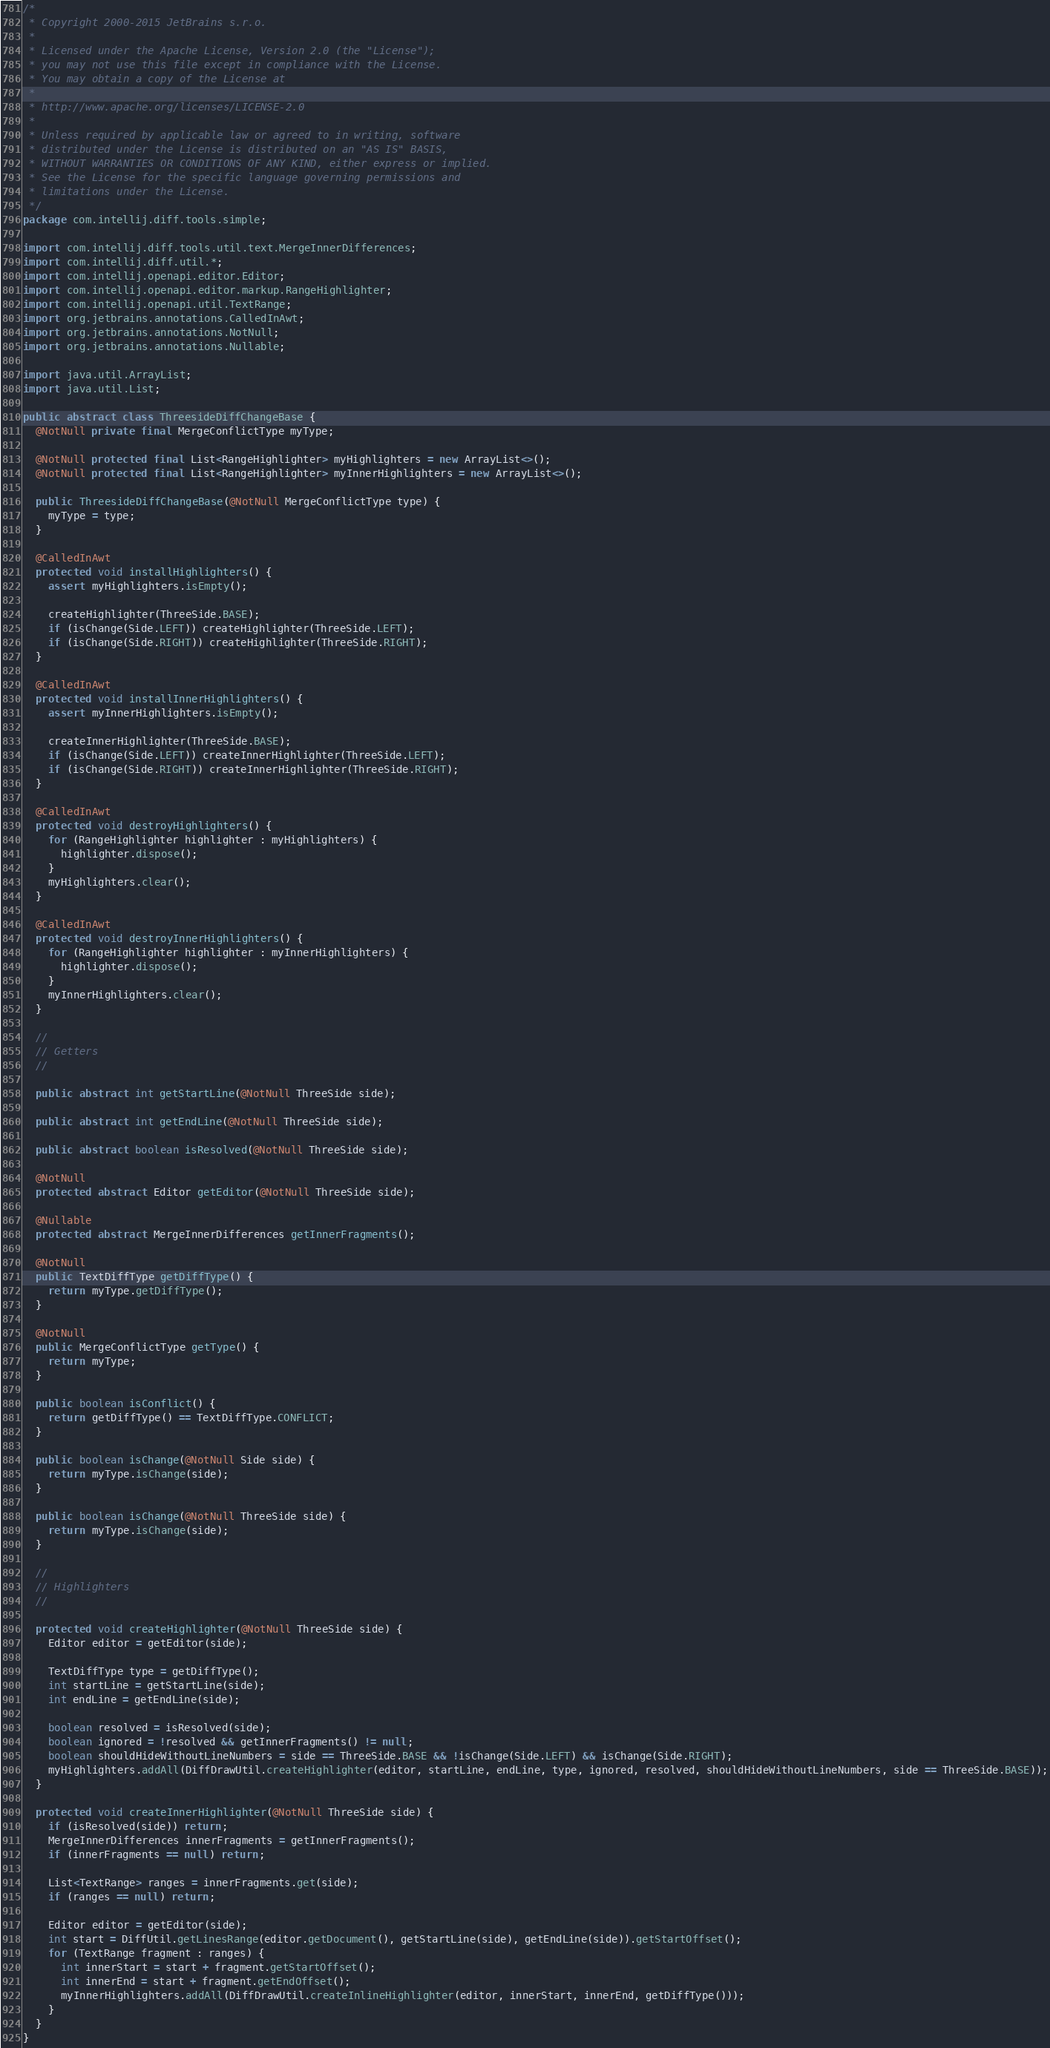<code> <loc_0><loc_0><loc_500><loc_500><_Java_>/*
 * Copyright 2000-2015 JetBrains s.r.o.
 *
 * Licensed under the Apache License, Version 2.0 (the "License");
 * you may not use this file except in compliance with the License.
 * You may obtain a copy of the License at
 *
 * http://www.apache.org/licenses/LICENSE-2.0
 *
 * Unless required by applicable law or agreed to in writing, software
 * distributed under the License is distributed on an "AS IS" BASIS,
 * WITHOUT WARRANTIES OR CONDITIONS OF ANY KIND, either express or implied.
 * See the License for the specific language governing permissions and
 * limitations under the License.
 */
package com.intellij.diff.tools.simple;

import com.intellij.diff.tools.util.text.MergeInnerDifferences;
import com.intellij.diff.util.*;
import com.intellij.openapi.editor.Editor;
import com.intellij.openapi.editor.markup.RangeHighlighter;
import com.intellij.openapi.util.TextRange;
import org.jetbrains.annotations.CalledInAwt;
import org.jetbrains.annotations.NotNull;
import org.jetbrains.annotations.Nullable;

import java.util.ArrayList;
import java.util.List;

public abstract class ThreesideDiffChangeBase {
  @NotNull private final MergeConflictType myType;

  @NotNull protected final List<RangeHighlighter> myHighlighters = new ArrayList<>();
  @NotNull protected final List<RangeHighlighter> myInnerHighlighters = new ArrayList<>();

  public ThreesideDiffChangeBase(@NotNull MergeConflictType type) {
    myType = type;
  }

  @CalledInAwt
  protected void installHighlighters() {
    assert myHighlighters.isEmpty();

    createHighlighter(ThreeSide.BASE);
    if (isChange(Side.LEFT)) createHighlighter(ThreeSide.LEFT);
    if (isChange(Side.RIGHT)) createHighlighter(ThreeSide.RIGHT);
  }

  @CalledInAwt
  protected void installInnerHighlighters() {
    assert myInnerHighlighters.isEmpty();

    createInnerHighlighter(ThreeSide.BASE);
    if (isChange(Side.LEFT)) createInnerHighlighter(ThreeSide.LEFT);
    if (isChange(Side.RIGHT)) createInnerHighlighter(ThreeSide.RIGHT);
  }

  @CalledInAwt
  protected void destroyHighlighters() {
    for (RangeHighlighter highlighter : myHighlighters) {
      highlighter.dispose();
    }
    myHighlighters.clear();
  }

  @CalledInAwt
  protected void destroyInnerHighlighters() {
    for (RangeHighlighter highlighter : myInnerHighlighters) {
      highlighter.dispose();
    }
    myInnerHighlighters.clear();
  }

  //
  // Getters
  //

  public abstract int getStartLine(@NotNull ThreeSide side);

  public abstract int getEndLine(@NotNull ThreeSide side);

  public abstract boolean isResolved(@NotNull ThreeSide side);

  @NotNull
  protected abstract Editor getEditor(@NotNull ThreeSide side);

  @Nullable
  protected abstract MergeInnerDifferences getInnerFragments();

  @NotNull
  public TextDiffType getDiffType() {
    return myType.getDiffType();
  }

  @NotNull
  public MergeConflictType getType() {
    return myType;
  }

  public boolean isConflict() {
    return getDiffType() == TextDiffType.CONFLICT;
  }

  public boolean isChange(@NotNull Side side) {
    return myType.isChange(side);
  }

  public boolean isChange(@NotNull ThreeSide side) {
    return myType.isChange(side);
  }

  //
  // Highlighters
  //

  protected void createHighlighter(@NotNull ThreeSide side) {
    Editor editor = getEditor(side);

    TextDiffType type = getDiffType();
    int startLine = getStartLine(side);
    int endLine = getEndLine(side);

    boolean resolved = isResolved(side);
    boolean ignored = !resolved && getInnerFragments() != null;
    boolean shouldHideWithoutLineNumbers = side == ThreeSide.BASE && !isChange(Side.LEFT) && isChange(Side.RIGHT);
    myHighlighters.addAll(DiffDrawUtil.createHighlighter(editor, startLine, endLine, type, ignored, resolved, shouldHideWithoutLineNumbers, side == ThreeSide.BASE));
  }

  protected void createInnerHighlighter(@NotNull ThreeSide side) {
    if (isResolved(side)) return;
    MergeInnerDifferences innerFragments = getInnerFragments();
    if (innerFragments == null) return;

    List<TextRange> ranges = innerFragments.get(side);
    if (ranges == null) return;

    Editor editor = getEditor(side);
    int start = DiffUtil.getLinesRange(editor.getDocument(), getStartLine(side), getEndLine(side)).getStartOffset();
    for (TextRange fragment : ranges) {
      int innerStart = start + fragment.getStartOffset();
      int innerEnd = start + fragment.getEndOffset();
      myInnerHighlighters.addAll(DiffDrawUtil.createInlineHighlighter(editor, innerStart, innerEnd, getDiffType()));
    }
  }
}</code> 